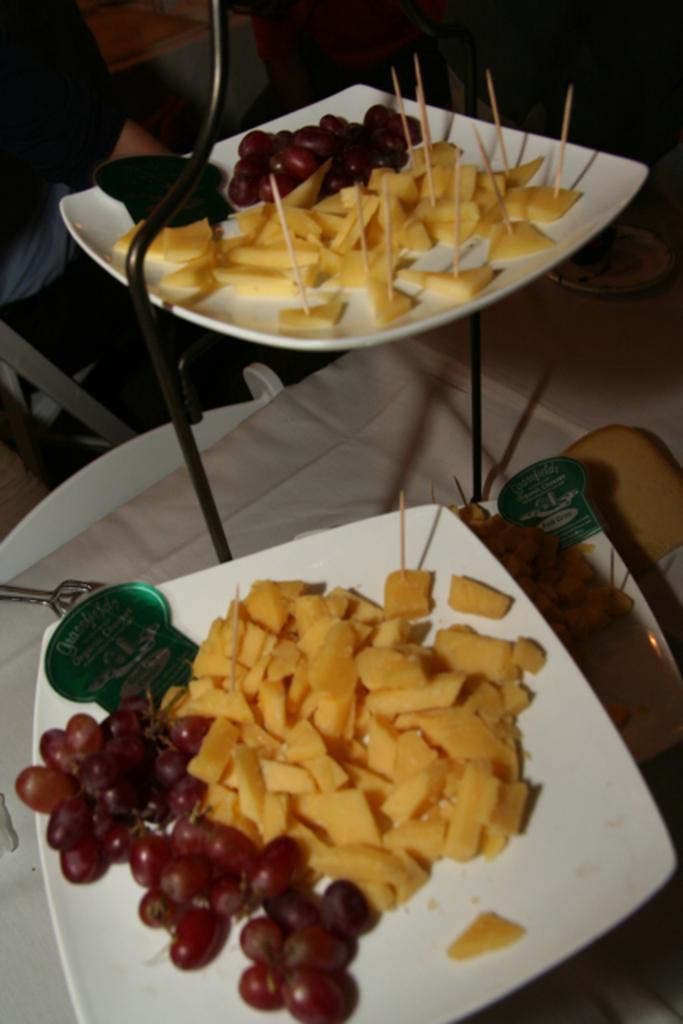Could you give a brief overview of what you see in this image? This image is taken indoors. At the bottom of the image there is a table with a table cloth and there are a few plates with salads on it. At the top of the image there is a man. 